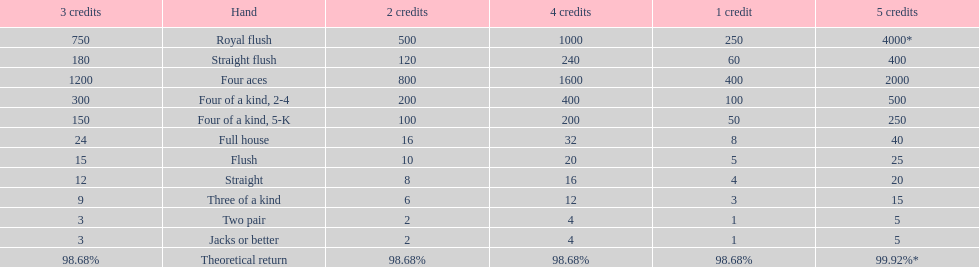What is the total amount of a 3 credit straight flush? 180. 